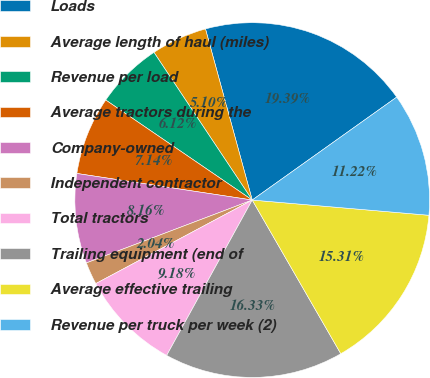Convert chart. <chart><loc_0><loc_0><loc_500><loc_500><pie_chart><fcel>Loads<fcel>Average length of haul (miles)<fcel>Revenue per load<fcel>Average tractors during the<fcel>Company-owned<fcel>Independent contractor<fcel>Total tractors<fcel>Trailing equipment (end of<fcel>Average effective trailing<fcel>Revenue per truck per week (2)<nl><fcel>19.39%<fcel>5.1%<fcel>6.12%<fcel>7.14%<fcel>8.16%<fcel>2.04%<fcel>9.18%<fcel>16.33%<fcel>15.31%<fcel>11.22%<nl></chart> 